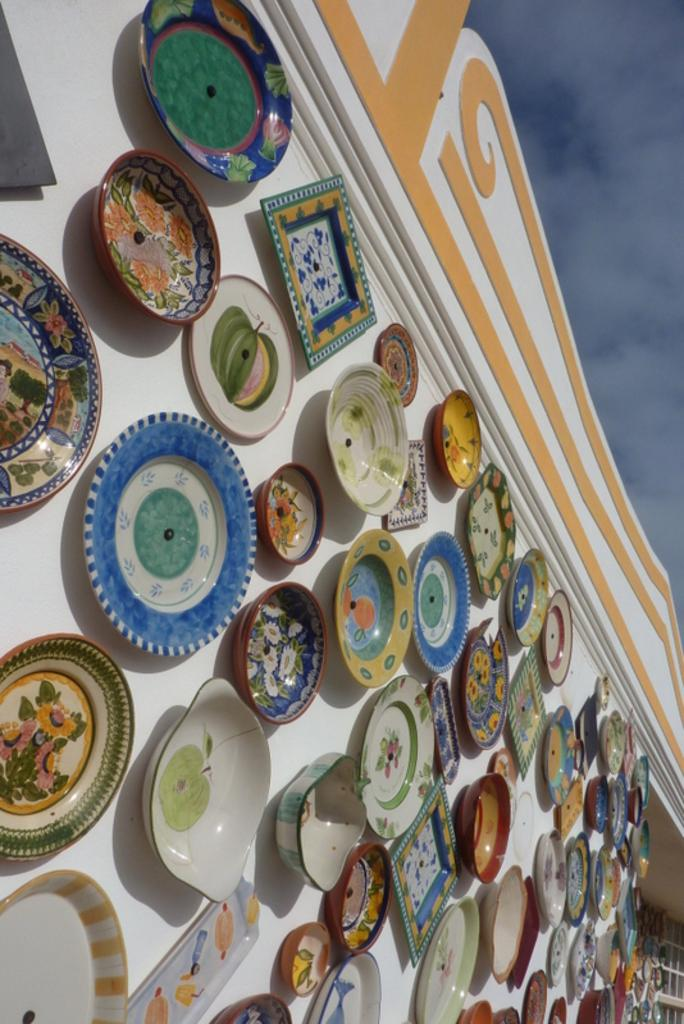What objects are hanging on the wall in the image? There are bowls, plates, and trays on the wall in the image. What is visible on the right side of the image? The right side of the image contains sky. What can be seen in the sky on the right side of the image? Clouds are visible in the sky on the right side of the image. Can you tell me how many geese are flying in the sky on the right side of the image? There are no geese visible in the sky on the right side of the image; only clouds are present. Is there a cobweb in the corner of the image? There is no mention of a cobweb in the provided facts, so it cannot be determined from the image. 